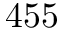<formula> <loc_0><loc_0><loc_500><loc_500>4 5 5</formula> 